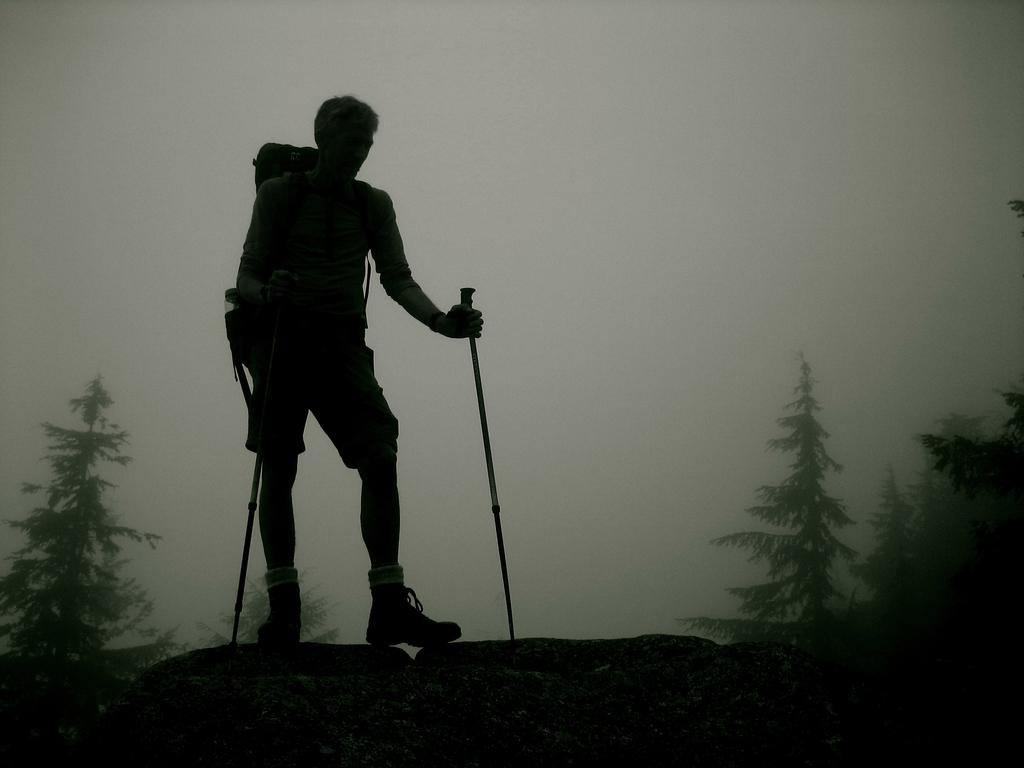What is the main subject of the image? There is a man in the image. What is the man doing in the image? The man is carrying a bag and holding sticks with his hands. What is the man's posture in the image? The man is standing. What can be seen in the background of the image? There are trees in the background of the image. What type of punishment is the man receiving in the image? There is no indication of punishment in the image; the man is simply carrying a bag and holding sticks. What is the man's elbow doing in the image? The man's elbow is not a focus of the image, as the facts provided do not mention it. 